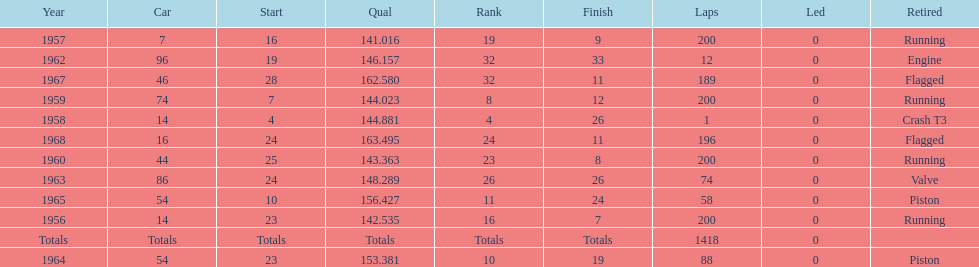What was the last year that it finished the race? 1968. 